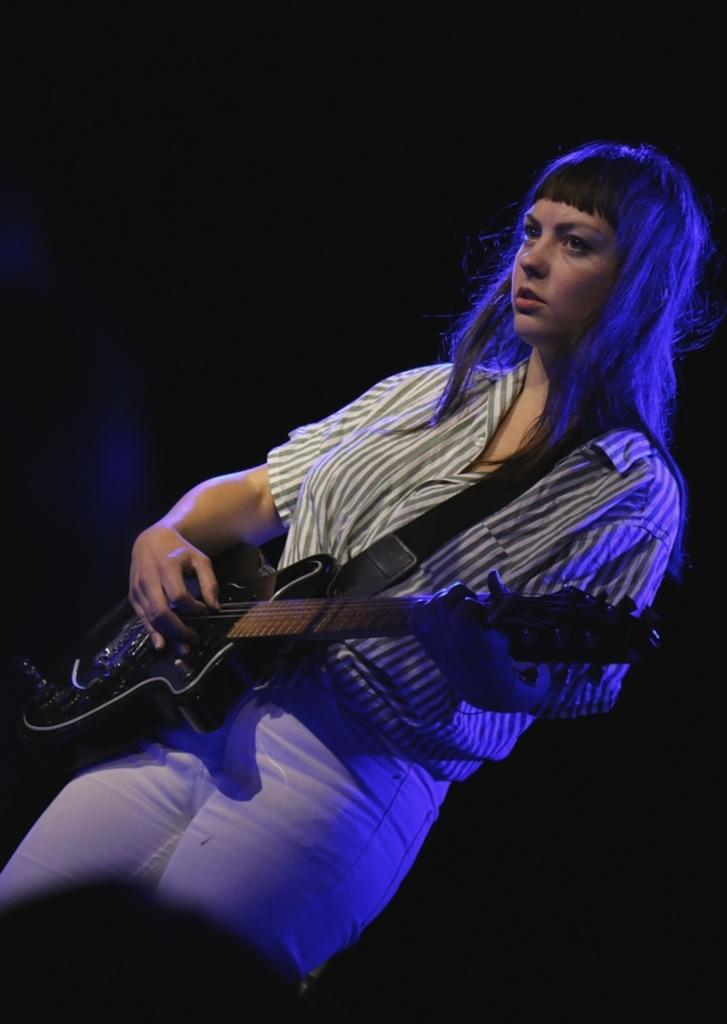Who is the main subject in the image? There is a girl in the image. Where is the girl positioned in the image? The girl is standing at the center of the image. What is the girl doing in the image? The girl is playing the guitar. What type of substance is the girl reading in the image? There is no substance present in the image, and the girl is not reading anything. 